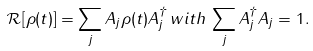<formula> <loc_0><loc_0><loc_500><loc_500>\mathcal { R } [ \rho ( t ) ] = \sum _ { j } A _ { j } \rho ( t ) A _ { j } ^ { \dagger } \, w i t h \, \sum _ { j } A _ { j } ^ { \dagger } A _ { j } = 1 .</formula> 